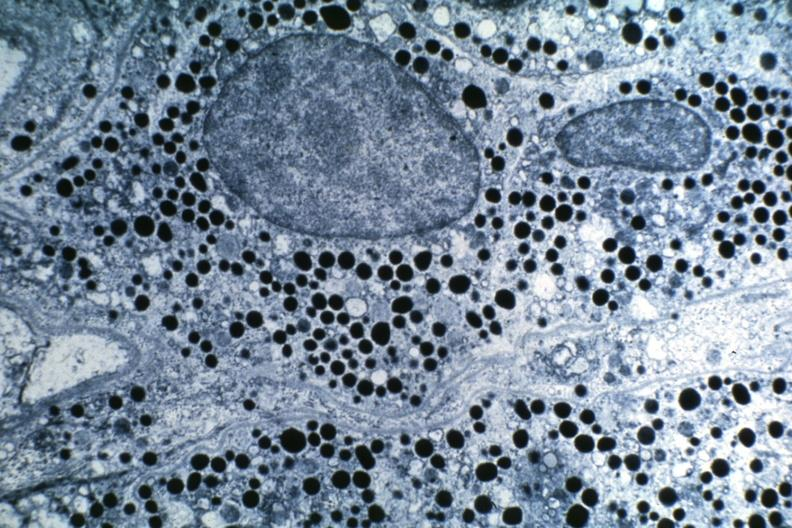what is present?
Answer the question using a single word or phrase. Adenoma 